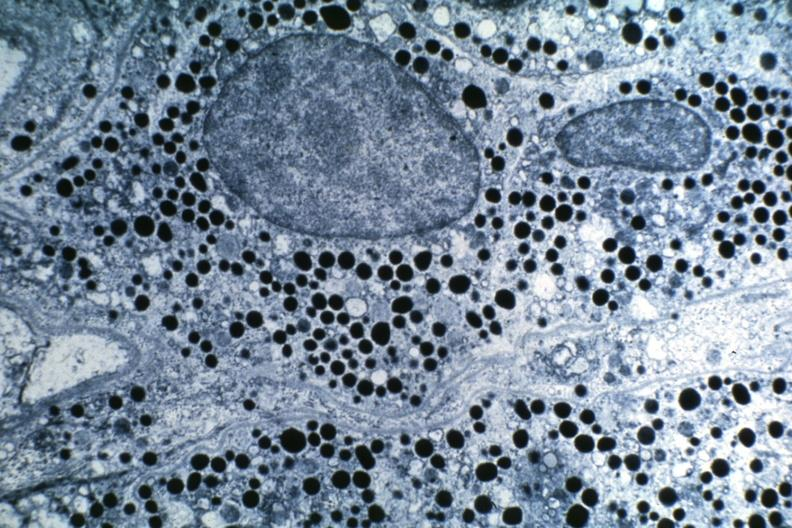what is present?
Answer the question using a single word or phrase. Adenoma 